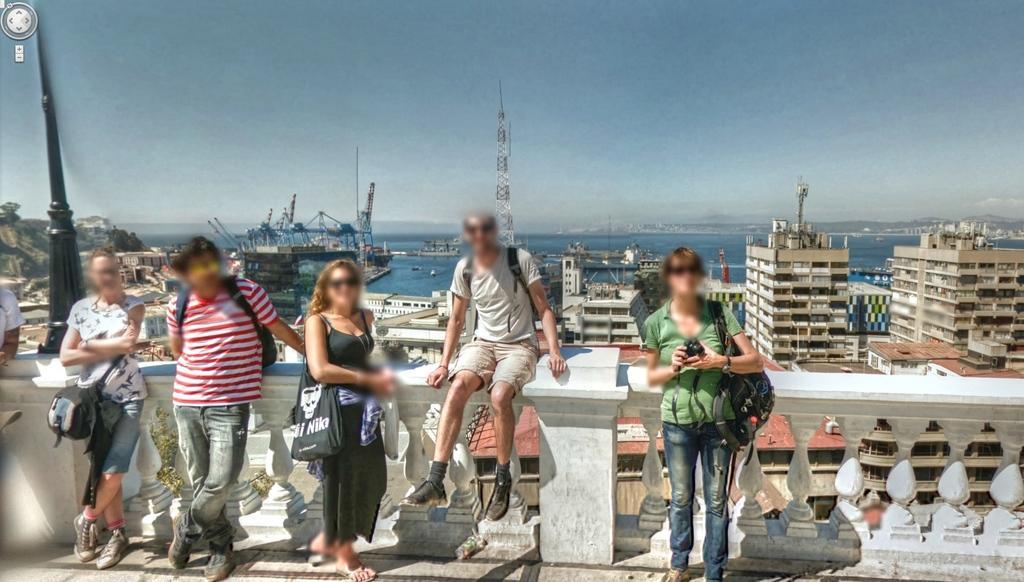Can you describe this image briefly? In this image I can see six persons are wearing bags. In the background I can see a fence, buildings, tower, mountains and boats in the water. On the top I can see the sky. This image is taken during a day. 